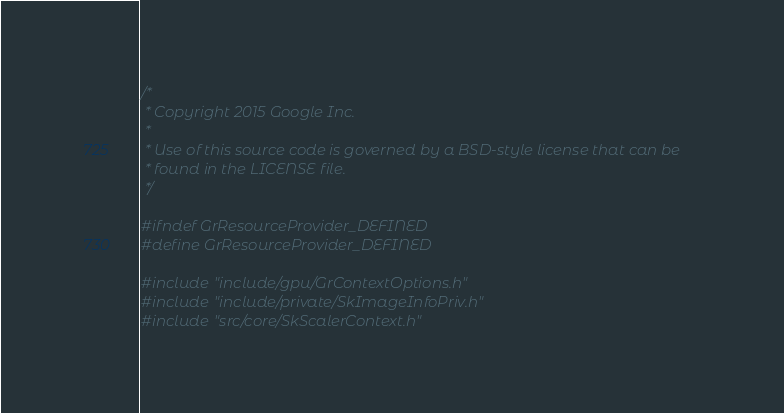Convert code to text. <code><loc_0><loc_0><loc_500><loc_500><_C_>/*
 * Copyright 2015 Google Inc.
 *
 * Use of this source code is governed by a BSD-style license that can be
 * found in the LICENSE file.
 */

#ifndef GrResourceProvider_DEFINED
#define GrResourceProvider_DEFINED

#include "include/gpu/GrContextOptions.h"
#include "include/private/SkImageInfoPriv.h"
#include "src/core/SkScalerContext.h"</code> 